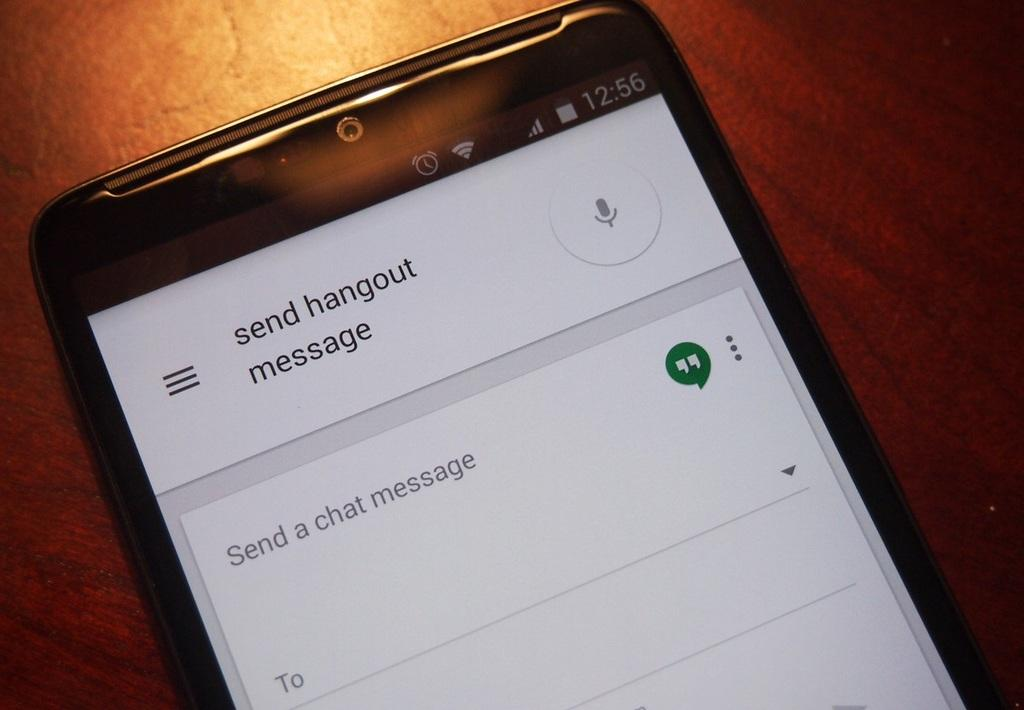<image>
Offer a succinct explanation of the picture presented. A phone screen says that someone can send a hangout message. 